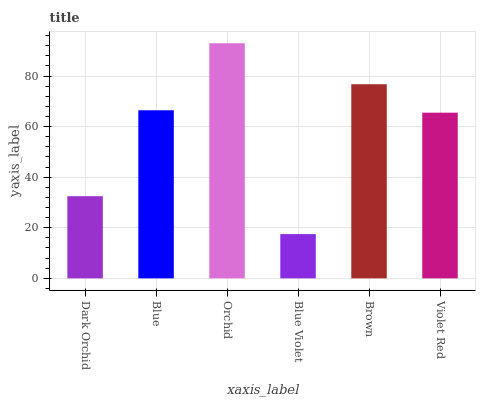Is Blue Violet the minimum?
Answer yes or no. Yes. Is Orchid the maximum?
Answer yes or no. Yes. Is Blue the minimum?
Answer yes or no. No. Is Blue the maximum?
Answer yes or no. No. Is Blue greater than Dark Orchid?
Answer yes or no. Yes. Is Dark Orchid less than Blue?
Answer yes or no. Yes. Is Dark Orchid greater than Blue?
Answer yes or no. No. Is Blue less than Dark Orchid?
Answer yes or no. No. Is Blue the high median?
Answer yes or no. Yes. Is Violet Red the low median?
Answer yes or no. Yes. Is Blue Violet the high median?
Answer yes or no. No. Is Dark Orchid the low median?
Answer yes or no. No. 